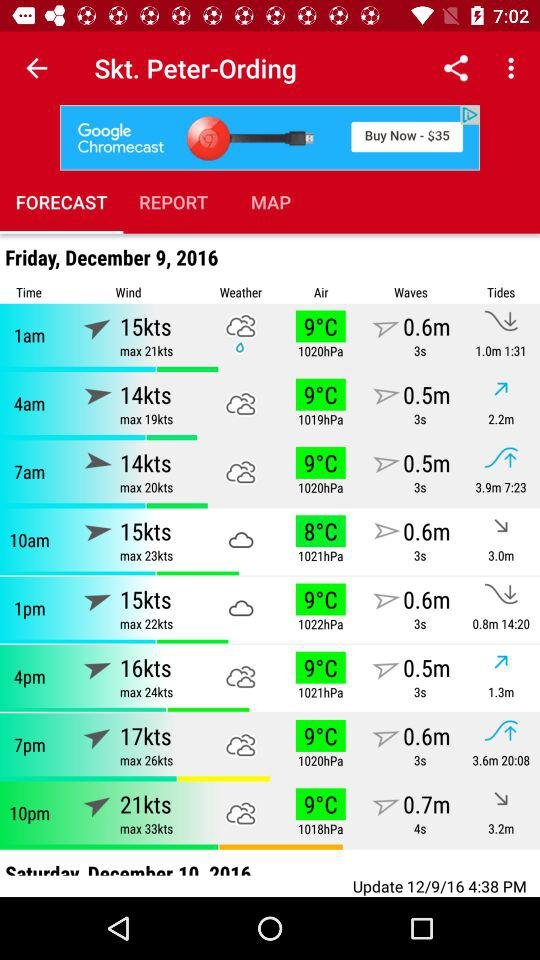What time was the forecast updated? The forecast was updated at 4:38 PM. 